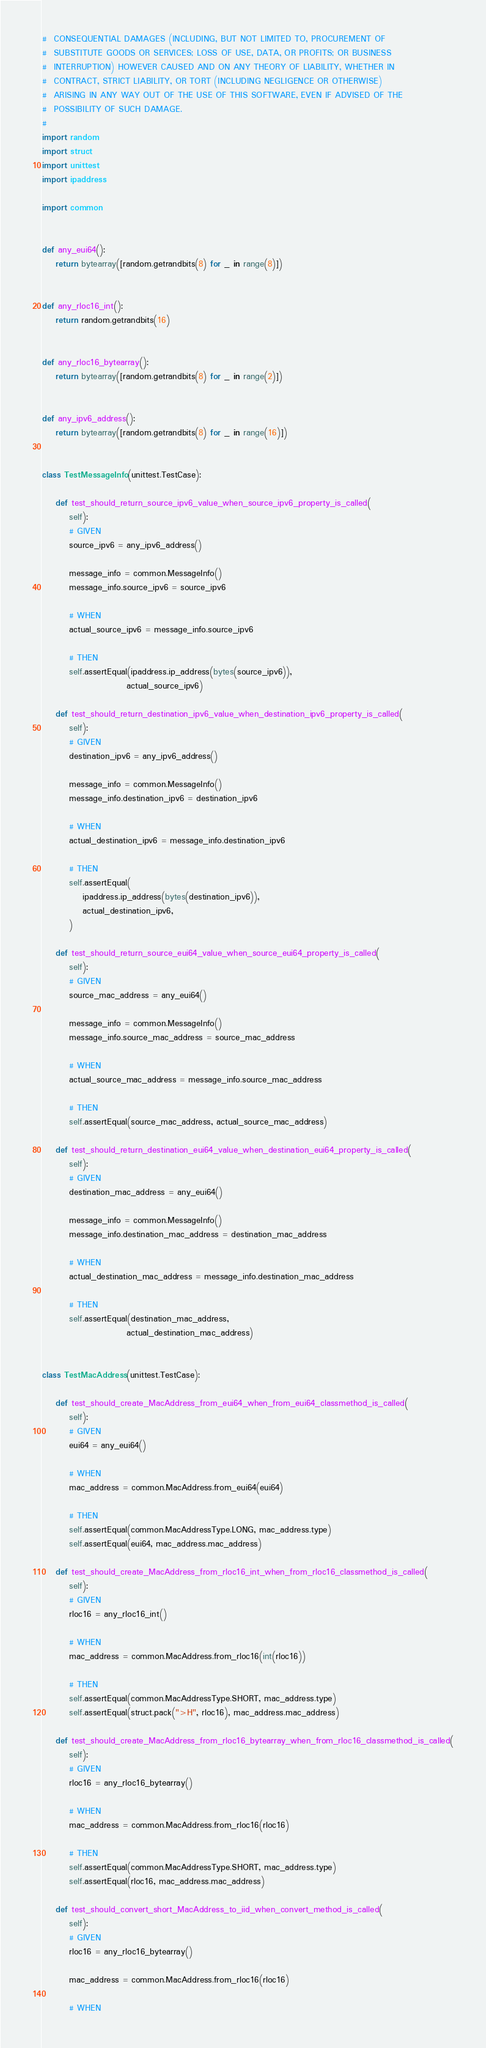<code> <loc_0><loc_0><loc_500><loc_500><_Python_>#  CONSEQUENTIAL DAMAGES (INCLUDING, BUT NOT LIMITED TO, PROCUREMENT OF
#  SUBSTITUTE GOODS OR SERVICES; LOSS OF USE, DATA, OR PROFITS; OR BUSINESS
#  INTERRUPTION) HOWEVER CAUSED AND ON ANY THEORY OF LIABILITY, WHETHER IN
#  CONTRACT, STRICT LIABILITY, OR TORT (INCLUDING NEGLIGENCE OR OTHERWISE)
#  ARISING IN ANY WAY OUT OF THE USE OF THIS SOFTWARE, EVEN IF ADVISED OF THE
#  POSSIBILITY OF SUCH DAMAGE.
#
import random
import struct
import unittest
import ipaddress

import common


def any_eui64():
    return bytearray([random.getrandbits(8) for _ in range(8)])


def any_rloc16_int():
    return random.getrandbits(16)


def any_rloc16_bytearray():
    return bytearray([random.getrandbits(8) for _ in range(2)])


def any_ipv6_address():
    return bytearray([random.getrandbits(8) for _ in range(16)])


class TestMessageInfo(unittest.TestCase):

    def test_should_return_source_ipv6_value_when_source_ipv6_property_is_called(
        self):
        # GIVEN
        source_ipv6 = any_ipv6_address()

        message_info = common.MessageInfo()
        message_info.source_ipv6 = source_ipv6

        # WHEN
        actual_source_ipv6 = message_info.source_ipv6

        # THEN
        self.assertEqual(ipaddress.ip_address(bytes(source_ipv6)),
                         actual_source_ipv6)

    def test_should_return_destination_ipv6_value_when_destination_ipv6_property_is_called(
        self):
        # GIVEN
        destination_ipv6 = any_ipv6_address()

        message_info = common.MessageInfo()
        message_info.destination_ipv6 = destination_ipv6

        # WHEN
        actual_destination_ipv6 = message_info.destination_ipv6

        # THEN
        self.assertEqual(
            ipaddress.ip_address(bytes(destination_ipv6)),
            actual_destination_ipv6,
        )

    def test_should_return_source_eui64_value_when_source_eui64_property_is_called(
        self):
        # GIVEN
        source_mac_address = any_eui64()

        message_info = common.MessageInfo()
        message_info.source_mac_address = source_mac_address

        # WHEN
        actual_source_mac_address = message_info.source_mac_address

        # THEN
        self.assertEqual(source_mac_address, actual_source_mac_address)

    def test_should_return_destination_eui64_value_when_destination_eui64_property_is_called(
        self):
        # GIVEN
        destination_mac_address = any_eui64()

        message_info = common.MessageInfo()
        message_info.destination_mac_address = destination_mac_address

        # WHEN
        actual_destination_mac_address = message_info.destination_mac_address

        # THEN
        self.assertEqual(destination_mac_address,
                         actual_destination_mac_address)


class TestMacAddress(unittest.TestCase):

    def test_should_create_MacAddress_from_eui64_when_from_eui64_classmethod_is_called(
        self):
        # GIVEN
        eui64 = any_eui64()

        # WHEN
        mac_address = common.MacAddress.from_eui64(eui64)

        # THEN
        self.assertEqual(common.MacAddressType.LONG, mac_address.type)
        self.assertEqual(eui64, mac_address.mac_address)

    def test_should_create_MacAddress_from_rloc16_int_when_from_rloc16_classmethod_is_called(
        self):
        # GIVEN
        rloc16 = any_rloc16_int()

        # WHEN
        mac_address = common.MacAddress.from_rloc16(int(rloc16))

        # THEN
        self.assertEqual(common.MacAddressType.SHORT, mac_address.type)
        self.assertEqual(struct.pack(">H", rloc16), mac_address.mac_address)

    def test_should_create_MacAddress_from_rloc16_bytearray_when_from_rloc16_classmethod_is_called(
        self):
        # GIVEN
        rloc16 = any_rloc16_bytearray()

        # WHEN
        mac_address = common.MacAddress.from_rloc16(rloc16)

        # THEN
        self.assertEqual(common.MacAddressType.SHORT, mac_address.type)
        self.assertEqual(rloc16, mac_address.mac_address)

    def test_should_convert_short_MacAddress_to_iid_when_convert_method_is_called(
        self):
        # GIVEN
        rloc16 = any_rloc16_bytearray()

        mac_address = common.MacAddress.from_rloc16(rloc16)

        # WHEN</code> 